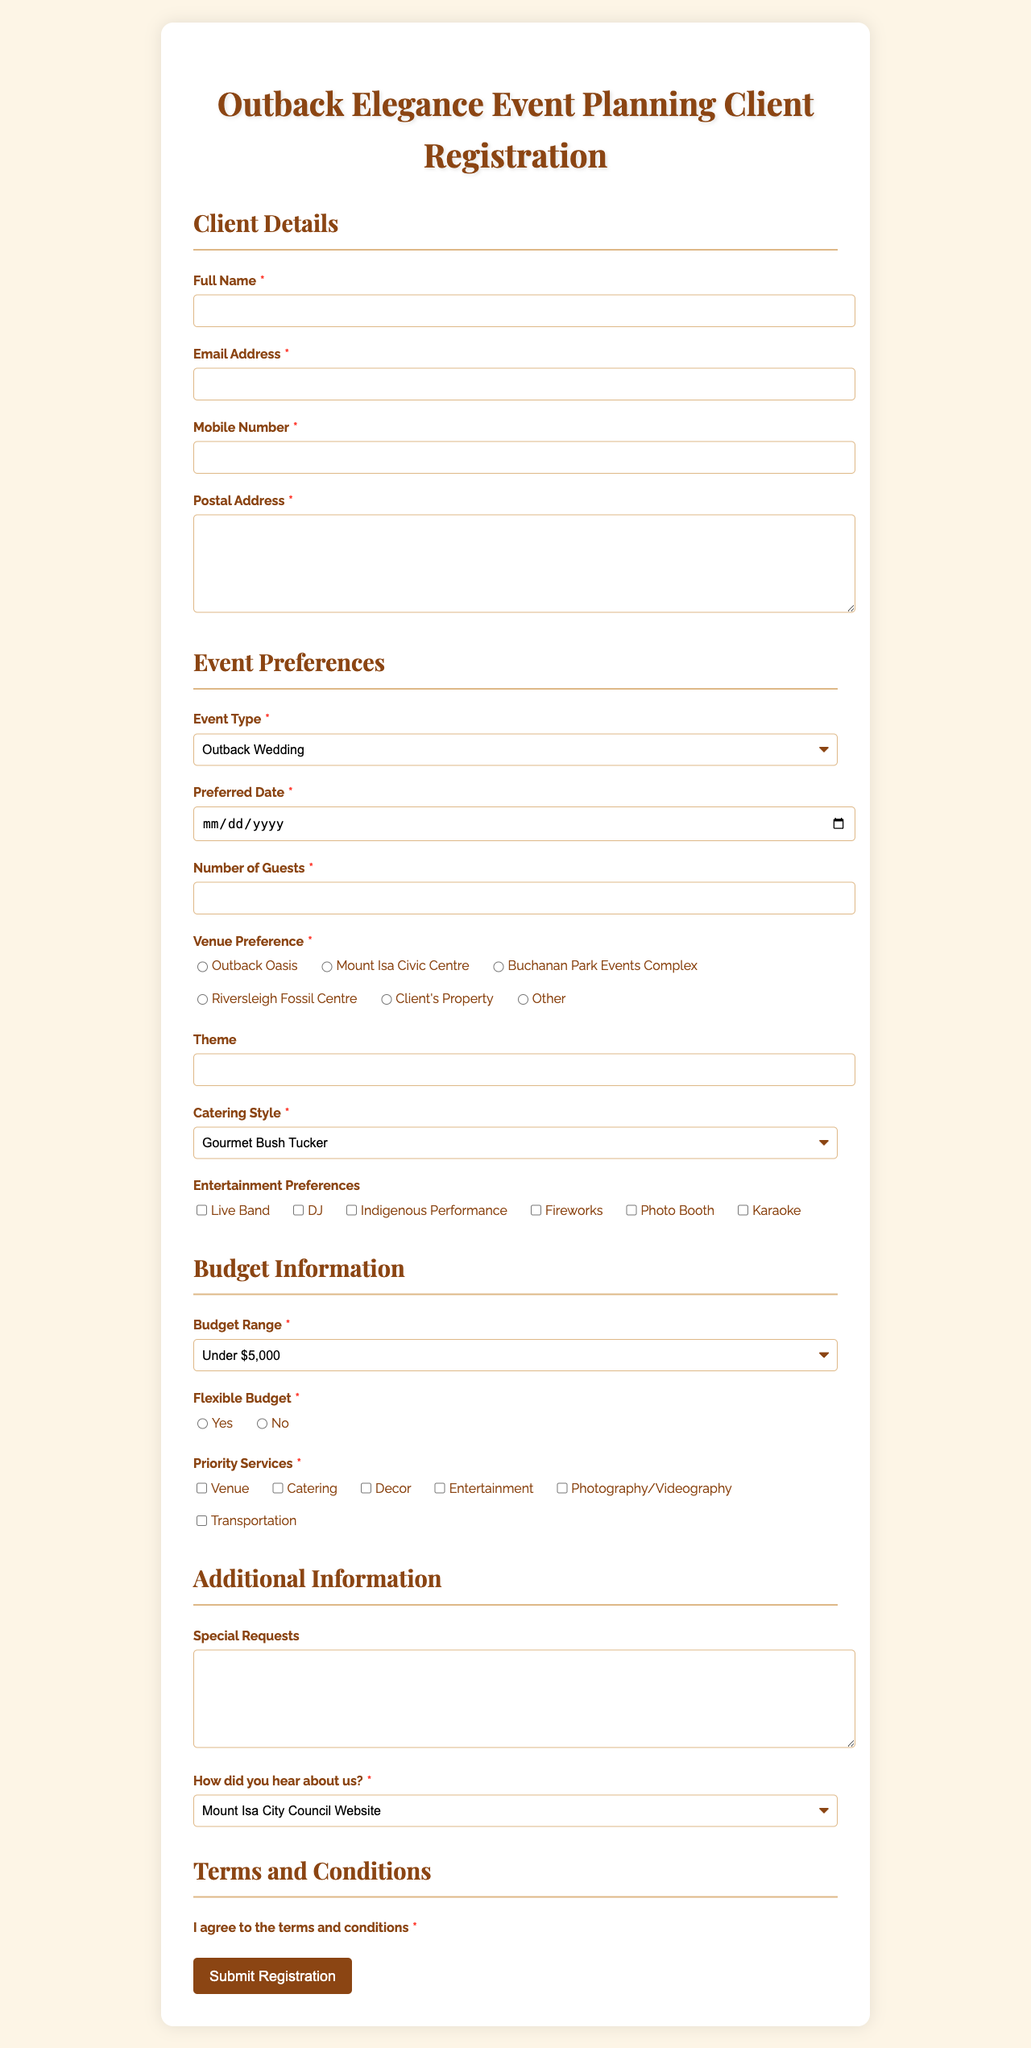what is the title of the form? The title of the form is specified at the top of the document.
Answer: Outback Elegance Event Planning Client Registration which company is providing the event planning services? The company name is mentioned in the document.
Answer: Mount Isa Soirées how many types of event can the client choose from? The options for event types are listed in the event preferences section, counting the listed items yields the total.
Answer: 6 what catering styles are available for selection? The document lists specific catering style options in a dropdown, making this a retrieval question.
Answer: Gourmet Bush Tucker, Modern Australian, International Cuisine, Cocktail and Canapés, BBQ and Grill, Vegetarian/Vegan what is the maximum budget range option available in the form? The budget section presents various budget ranges, with the highest being the last option listed.
Answer: Over $50,000 if a client has special requests, which field should they use? The document includes an open-ended field for this purpose.
Answer: Special Requests which event type is not explicitly listed in the options provided? Reasoning through the options allows for identifying an absence in the specified event types.
Answer: Engagement Party how can the client submit the registration? The document concludes with a specific button allowing for submission of the form.
Answer: Submit Registration 